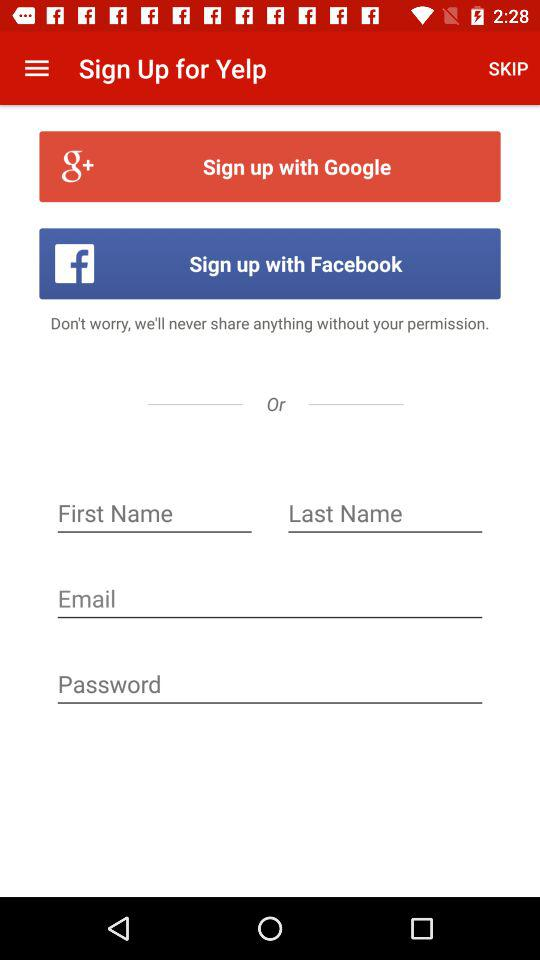How many social media login options are there on this screen?
Answer the question using a single word or phrase. 2 